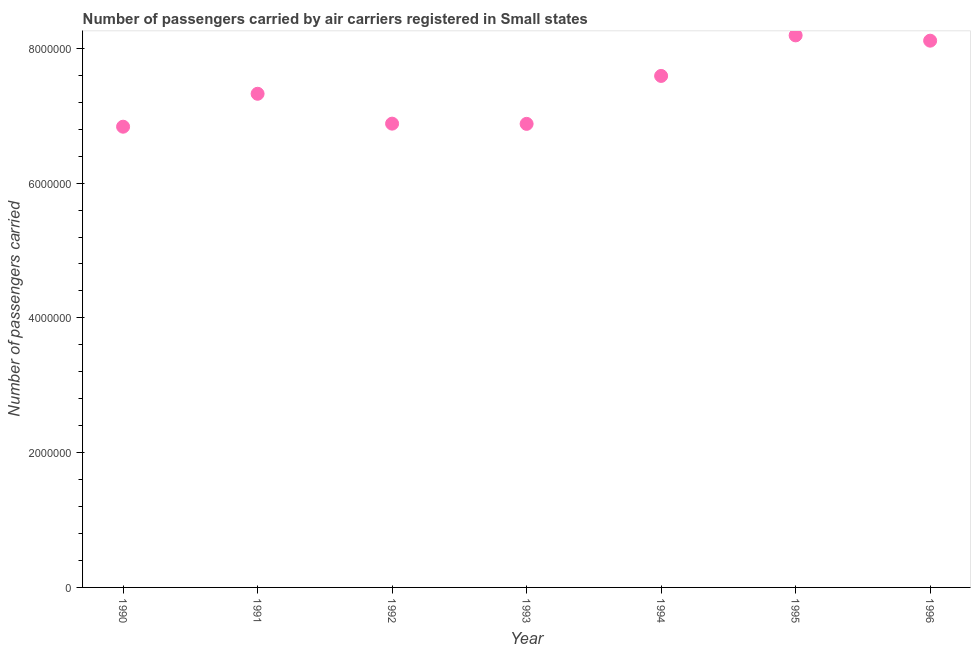What is the number of passengers carried in 1996?
Provide a succinct answer. 8.11e+06. Across all years, what is the maximum number of passengers carried?
Provide a short and direct response. 8.19e+06. Across all years, what is the minimum number of passengers carried?
Your answer should be very brief. 6.84e+06. In which year was the number of passengers carried minimum?
Your response must be concise. 1990. What is the sum of the number of passengers carried?
Provide a succinct answer. 5.18e+07. What is the difference between the number of passengers carried in 1991 and 1994?
Make the answer very short. -2.65e+05. What is the average number of passengers carried per year?
Offer a terse response. 7.40e+06. What is the median number of passengers carried?
Provide a short and direct response. 7.33e+06. Do a majority of the years between 1995 and 1994 (inclusive) have number of passengers carried greater than 4800000 ?
Give a very brief answer. No. What is the ratio of the number of passengers carried in 1995 to that in 1996?
Offer a terse response. 1.01. Is the number of passengers carried in 1991 less than that in 1994?
Provide a succinct answer. Yes. What is the difference between the highest and the second highest number of passengers carried?
Make the answer very short. 7.84e+04. What is the difference between the highest and the lowest number of passengers carried?
Provide a short and direct response. 1.36e+06. How many dotlines are there?
Offer a terse response. 1. What is the difference between two consecutive major ticks on the Y-axis?
Make the answer very short. 2.00e+06. Are the values on the major ticks of Y-axis written in scientific E-notation?
Make the answer very short. No. Does the graph contain any zero values?
Offer a terse response. No. Does the graph contain grids?
Provide a succinct answer. No. What is the title of the graph?
Offer a very short reply. Number of passengers carried by air carriers registered in Small states. What is the label or title of the X-axis?
Offer a very short reply. Year. What is the label or title of the Y-axis?
Ensure brevity in your answer.  Number of passengers carried. What is the Number of passengers carried in 1990?
Your answer should be compact. 6.84e+06. What is the Number of passengers carried in 1991?
Offer a very short reply. 7.33e+06. What is the Number of passengers carried in 1992?
Offer a very short reply. 6.88e+06. What is the Number of passengers carried in 1993?
Your response must be concise. 6.88e+06. What is the Number of passengers carried in 1994?
Provide a succinct answer. 7.59e+06. What is the Number of passengers carried in 1995?
Make the answer very short. 8.19e+06. What is the Number of passengers carried in 1996?
Provide a succinct answer. 8.11e+06. What is the difference between the Number of passengers carried in 1990 and 1991?
Your answer should be compact. -4.89e+05. What is the difference between the Number of passengers carried in 1990 and 1992?
Your answer should be compact. -4.53e+04. What is the difference between the Number of passengers carried in 1990 and 1993?
Your response must be concise. -4.20e+04. What is the difference between the Number of passengers carried in 1990 and 1994?
Provide a succinct answer. -7.54e+05. What is the difference between the Number of passengers carried in 1990 and 1995?
Your answer should be compact. -1.36e+06. What is the difference between the Number of passengers carried in 1990 and 1996?
Give a very brief answer. -1.28e+06. What is the difference between the Number of passengers carried in 1991 and 1992?
Provide a succinct answer. 4.43e+05. What is the difference between the Number of passengers carried in 1991 and 1993?
Your answer should be very brief. 4.47e+05. What is the difference between the Number of passengers carried in 1991 and 1994?
Offer a terse response. -2.65e+05. What is the difference between the Number of passengers carried in 1991 and 1995?
Your response must be concise. -8.66e+05. What is the difference between the Number of passengers carried in 1991 and 1996?
Ensure brevity in your answer.  -7.88e+05. What is the difference between the Number of passengers carried in 1992 and 1993?
Provide a succinct answer. 3300. What is the difference between the Number of passengers carried in 1992 and 1994?
Make the answer very short. -7.08e+05. What is the difference between the Number of passengers carried in 1992 and 1995?
Offer a very short reply. -1.31e+06. What is the difference between the Number of passengers carried in 1992 and 1996?
Offer a terse response. -1.23e+06. What is the difference between the Number of passengers carried in 1993 and 1994?
Your answer should be very brief. -7.12e+05. What is the difference between the Number of passengers carried in 1993 and 1995?
Provide a succinct answer. -1.31e+06. What is the difference between the Number of passengers carried in 1993 and 1996?
Ensure brevity in your answer.  -1.23e+06. What is the difference between the Number of passengers carried in 1994 and 1995?
Give a very brief answer. -6.02e+05. What is the difference between the Number of passengers carried in 1994 and 1996?
Your answer should be very brief. -5.23e+05. What is the difference between the Number of passengers carried in 1995 and 1996?
Your response must be concise. 7.84e+04. What is the ratio of the Number of passengers carried in 1990 to that in 1991?
Your answer should be compact. 0.93. What is the ratio of the Number of passengers carried in 1990 to that in 1993?
Make the answer very short. 0.99. What is the ratio of the Number of passengers carried in 1990 to that in 1994?
Offer a very short reply. 0.9. What is the ratio of the Number of passengers carried in 1990 to that in 1995?
Keep it short and to the point. 0.83. What is the ratio of the Number of passengers carried in 1990 to that in 1996?
Provide a succinct answer. 0.84. What is the ratio of the Number of passengers carried in 1991 to that in 1992?
Make the answer very short. 1.06. What is the ratio of the Number of passengers carried in 1991 to that in 1993?
Provide a succinct answer. 1.06. What is the ratio of the Number of passengers carried in 1991 to that in 1994?
Make the answer very short. 0.96. What is the ratio of the Number of passengers carried in 1991 to that in 1995?
Provide a succinct answer. 0.89. What is the ratio of the Number of passengers carried in 1991 to that in 1996?
Make the answer very short. 0.9. What is the ratio of the Number of passengers carried in 1992 to that in 1993?
Ensure brevity in your answer.  1. What is the ratio of the Number of passengers carried in 1992 to that in 1994?
Your answer should be very brief. 0.91. What is the ratio of the Number of passengers carried in 1992 to that in 1995?
Offer a terse response. 0.84. What is the ratio of the Number of passengers carried in 1992 to that in 1996?
Your response must be concise. 0.85. What is the ratio of the Number of passengers carried in 1993 to that in 1994?
Ensure brevity in your answer.  0.91. What is the ratio of the Number of passengers carried in 1993 to that in 1995?
Your answer should be compact. 0.84. What is the ratio of the Number of passengers carried in 1993 to that in 1996?
Give a very brief answer. 0.85. What is the ratio of the Number of passengers carried in 1994 to that in 1995?
Provide a succinct answer. 0.93. What is the ratio of the Number of passengers carried in 1994 to that in 1996?
Provide a succinct answer. 0.94. 